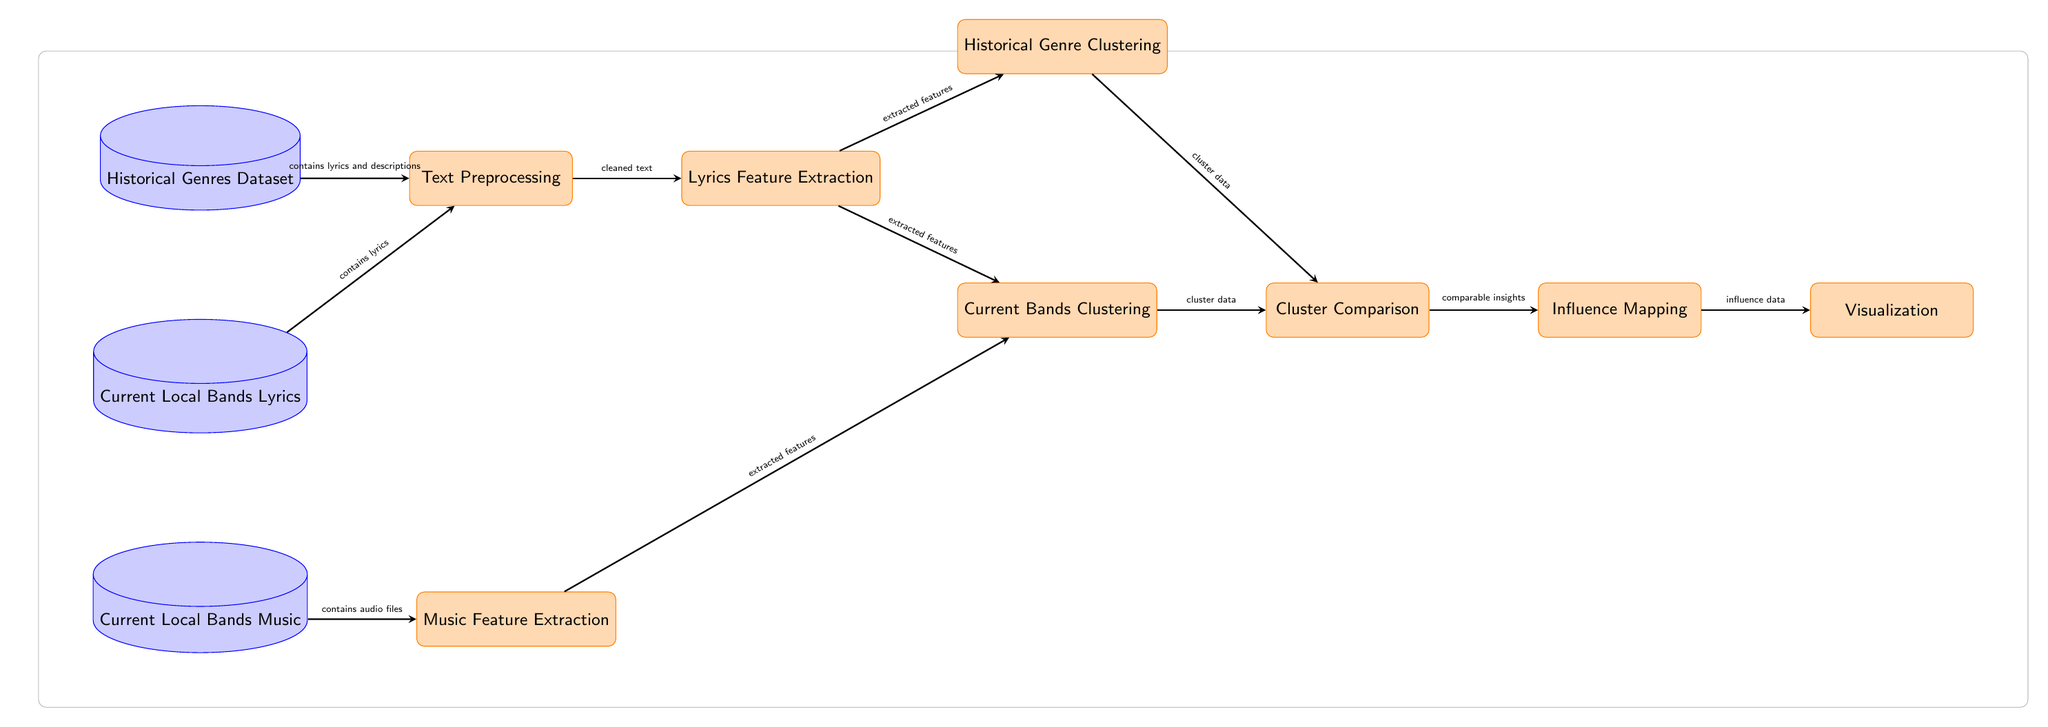What is the first dataset used in the diagram? The first dataset in the diagram is labeled as "Historical Genres Dataset." It is positioned at the top of the diagram, indicating it is the initial input for the process flow.
Answer: Historical Genres Dataset How many data nodes are present in the diagram? The diagram displays a total of three data nodes: "Historical Genres Dataset," "Current Local Bands Lyrics," and "Current Local Bands Music." This can be counted directly from the visual representation.
Answer: 3 What features are extracted after the text preprocessing step? After the "Text Preprocessing" step, the "Lyrics Feature Extraction" receives cleaned text, indicating that the output of the preprocessing is the extracted features which are passed on for further analysis.
Answer: Extracted features Which process node comes after "Current Bands Clustering"? The process that follows "Current Bands Clustering" is "Cluster Comparison," as shown by the directed arrow indicating the flow of data from one process to the next.
Answer: Cluster Comparison How do the lyrics relate to historical genre clustering and current bands clustering? The lyrics are processed in the "Lyrics Feature Extraction" step, where extracted features are then forwarded to both "Historical Genre Clustering" and "Current Bands Clustering," indicating that they are utilized for both analyses.
Answer: Extracted features What type of data does the "Current Local Bands Music" node provide? The "Current Local Bands Music" node provides audio files, as described in the arrow connecting it to the "Music Feature Extraction" process node.
Answer: Audio files Which process is focused on comparing clusters derived from historical genres and current bands? The "Cluster Comparison" process is responsible for comparing the clusters resulting from the "Historical Genre Clustering" and "Current Bands Clustering," indicated by the direct connections from both to this node.
Answer: Cluster Comparison What is the final output of the diagram? The final output of the diagram flows from the "Influence Mapping" process to the "Visualization" process, indicating that the visualization represents the culmination of the entire analysis.
Answer: Visualization 